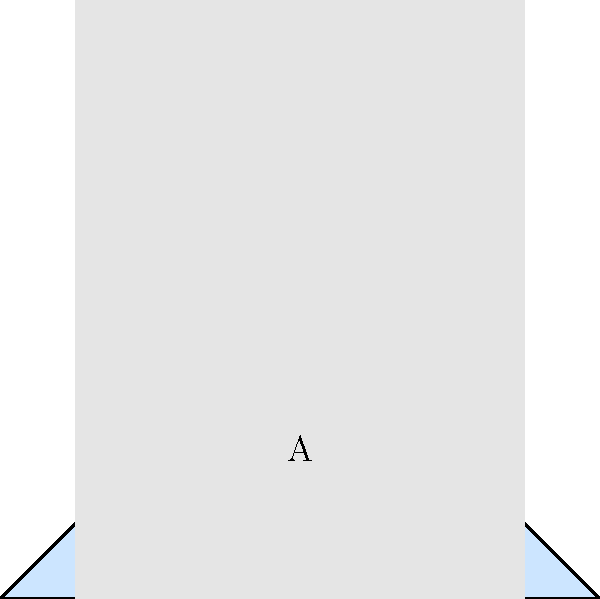As a financial advisor specializing in global real estate markets, you're developing a machine learning model to classify property types based on building exterior images. Given the simplified representations of three building types (A, B, and C) in the image above, which property type is most likely to have the highest price per square foot in a typical urban market? To answer this question, we need to analyze the characteristics of each building type and relate them to typical urban real estate market trends:

1. Building A: This triangular shape represents a residential property, likely a single-family home or small multi-unit building. It has a sloped roof and moderate height.

2. Building B: The rectangular shape with significant height represents a commercial property, such as an office building or retail space. It has the greatest vertical extension among the three.

3. Building C: The wide, low-profile structure represents an industrial property, such as a warehouse or manufacturing facility. It has the largest footprint but the lowest height.

In typical urban markets:

a) Commercial properties (B) often command the highest price per square foot due to:
   - Prime locations in central business districts
   - Potential for high-density usage (multiple floors)
   - Ability to generate rental income from multiple tenants

b) Residential properties (A) usually have the second-highest price per square foot:
   - Desirable for personal use
   - Can be in prime locations but often less central than commercial

c) Industrial properties (C) typically have the lowest price per square foot:
   - Often located in peripheral areas with lower land costs
   - Large footprints but less vertical development
   - Lower finish quality compared to commercial or residential

Given these factors, in a typical urban market, the commercial property (B) is most likely to have the highest price per square foot.
Answer: Commercial (B) 